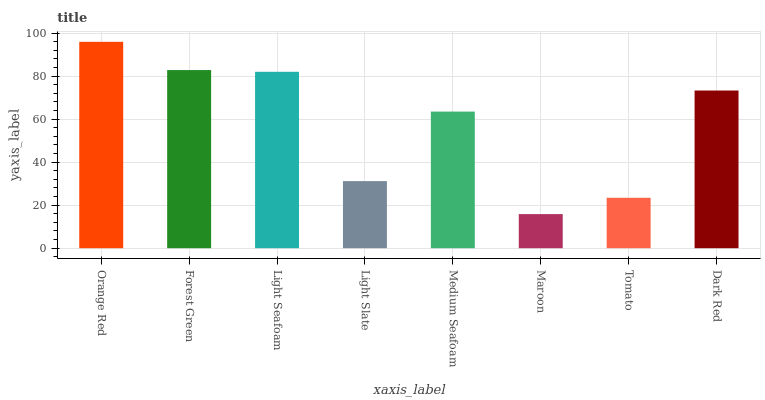Is Maroon the minimum?
Answer yes or no. Yes. Is Orange Red the maximum?
Answer yes or no. Yes. Is Forest Green the minimum?
Answer yes or no. No. Is Forest Green the maximum?
Answer yes or no. No. Is Orange Red greater than Forest Green?
Answer yes or no. Yes. Is Forest Green less than Orange Red?
Answer yes or no. Yes. Is Forest Green greater than Orange Red?
Answer yes or no. No. Is Orange Red less than Forest Green?
Answer yes or no. No. Is Dark Red the high median?
Answer yes or no. Yes. Is Medium Seafoam the low median?
Answer yes or no. Yes. Is Light Slate the high median?
Answer yes or no. No. Is Light Slate the low median?
Answer yes or no. No. 